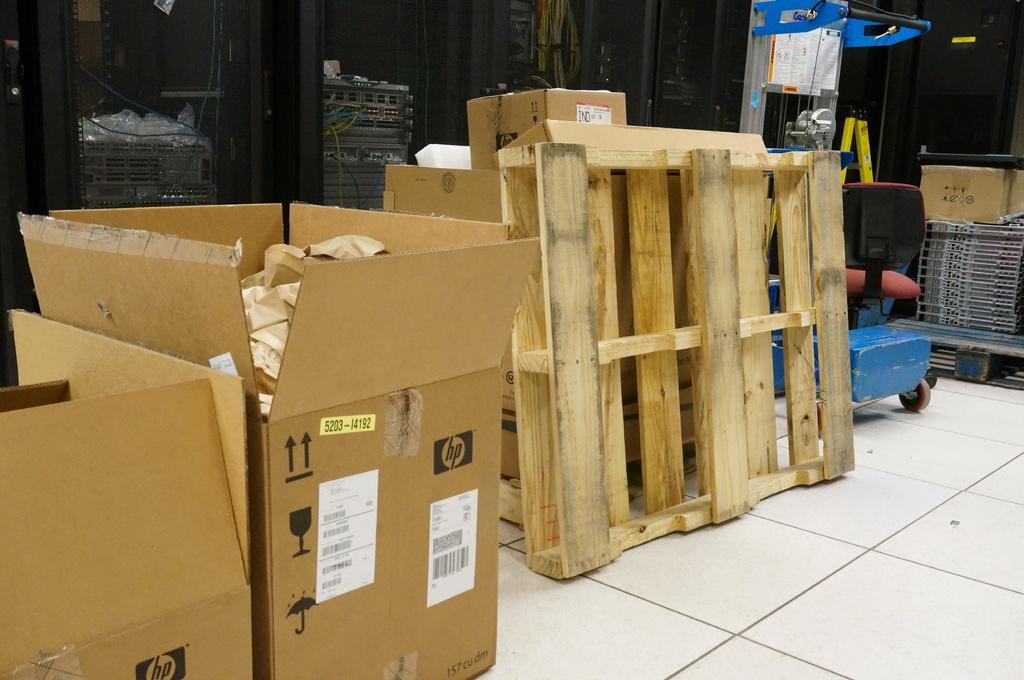Describe this image in one or two sentences. In the picture we can see a floor with white tiles, on it we can see some cardboard boxes which are opened and some papers in it beside we can see a chart with some things on it and they are placed near the wall which is black in color. 